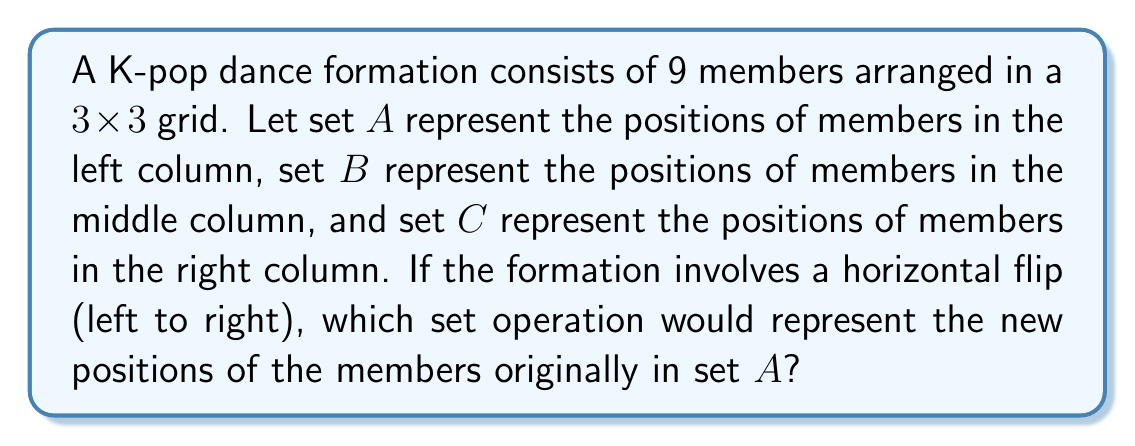Teach me how to tackle this problem. Let's approach this step-by-step:

1) First, we need to understand the initial arrangement:
   Set A = {left column positions}
   Set B = {middle column positions}
   Set C = {right column positions}

2) A horizontal flip means that the left column will become the right column, and vice versa. The middle column remains unchanged.

3) After the flip:
   - Members originally in set A will now occupy the positions in set C
   - Members originally in set B will remain in set B
   - Members originally in set C will now occupy the positions in set A

4) Therefore, the new positions of the members originally in set A are represented by set C.

5) In set theory, this is equivalent to the set operation of replacement or mapping. We are essentially mapping set A to set C.

6) This can be written as a function $f: A \rightarrow C$, where $f(a) = c$ for each $a \in A$ and its corresponding $c \in C$.

7) In terms of set operations, this is often denoted as $C$, as we are simply referring to the set C to represent the new positions of the members originally in set A.
Answer: $C$ 